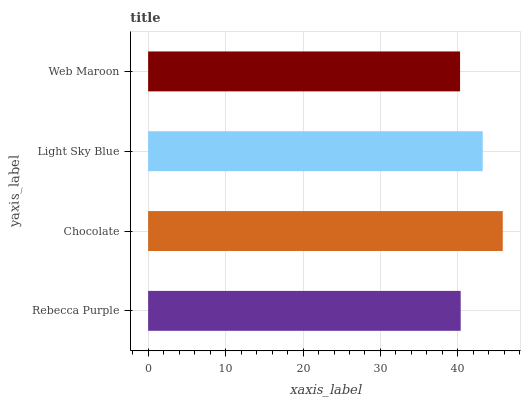Is Web Maroon the minimum?
Answer yes or no. Yes. Is Chocolate the maximum?
Answer yes or no. Yes. Is Light Sky Blue the minimum?
Answer yes or no. No. Is Light Sky Blue the maximum?
Answer yes or no. No. Is Chocolate greater than Light Sky Blue?
Answer yes or no. Yes. Is Light Sky Blue less than Chocolate?
Answer yes or no. Yes. Is Light Sky Blue greater than Chocolate?
Answer yes or no. No. Is Chocolate less than Light Sky Blue?
Answer yes or no. No. Is Light Sky Blue the high median?
Answer yes or no. Yes. Is Rebecca Purple the low median?
Answer yes or no. Yes. Is Chocolate the high median?
Answer yes or no. No. Is Chocolate the low median?
Answer yes or no. No. 